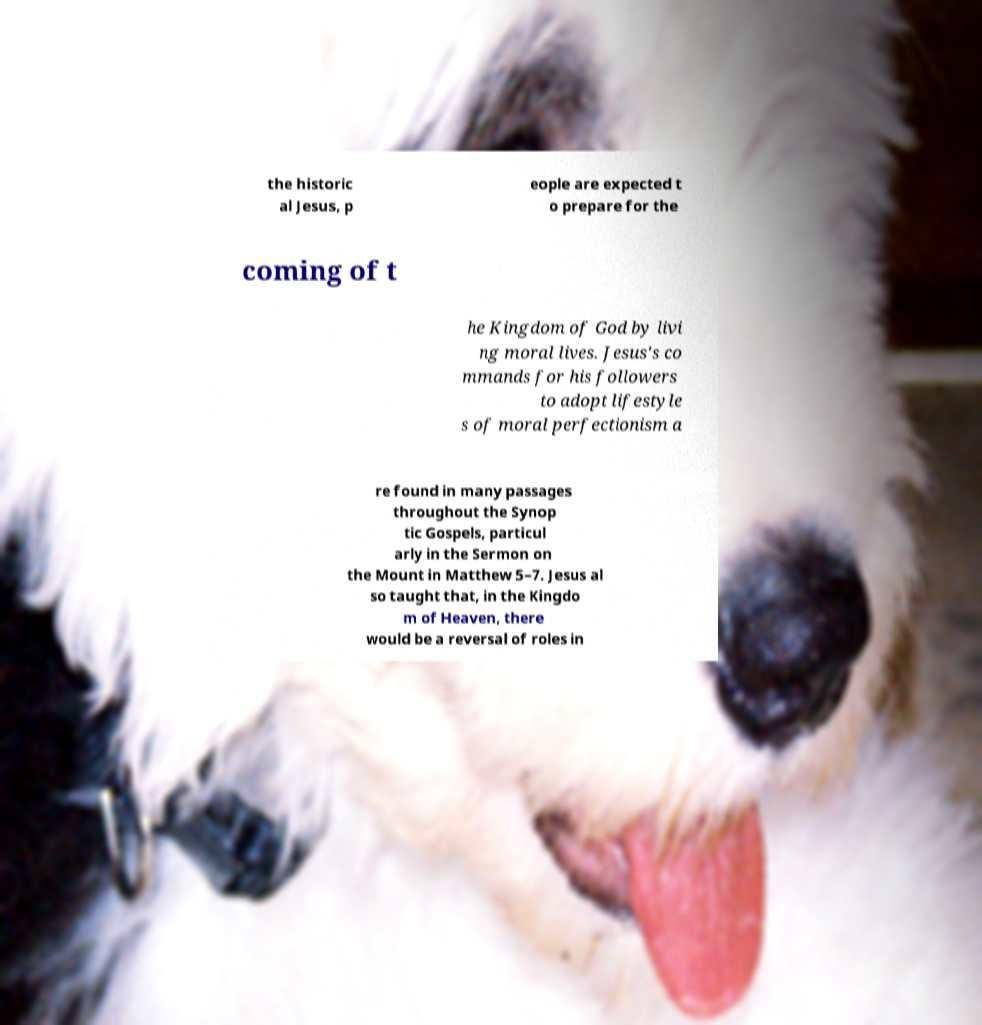Please read and relay the text visible in this image. What does it say? the historic al Jesus, p eople are expected t o prepare for the coming of t he Kingdom of God by livi ng moral lives. Jesus's co mmands for his followers to adopt lifestyle s of moral perfectionism a re found in many passages throughout the Synop tic Gospels, particul arly in the Sermon on the Mount in Matthew 5–7. Jesus al so taught that, in the Kingdo m of Heaven, there would be a reversal of roles in 